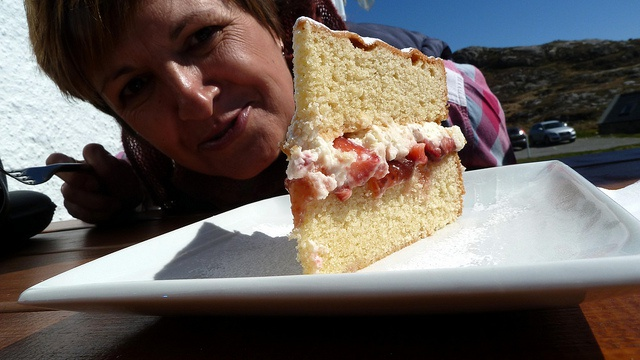Describe the objects in this image and their specific colors. I can see people in lightblue, black, maroon, gray, and salmon tones, cake in lightblue, tan, and beige tones, fork in lightblue, black, gray, lightgray, and navy tones, car in lightblue, black, gray, and darkgray tones, and car in lightblue, black, gray, white, and darkblue tones in this image. 